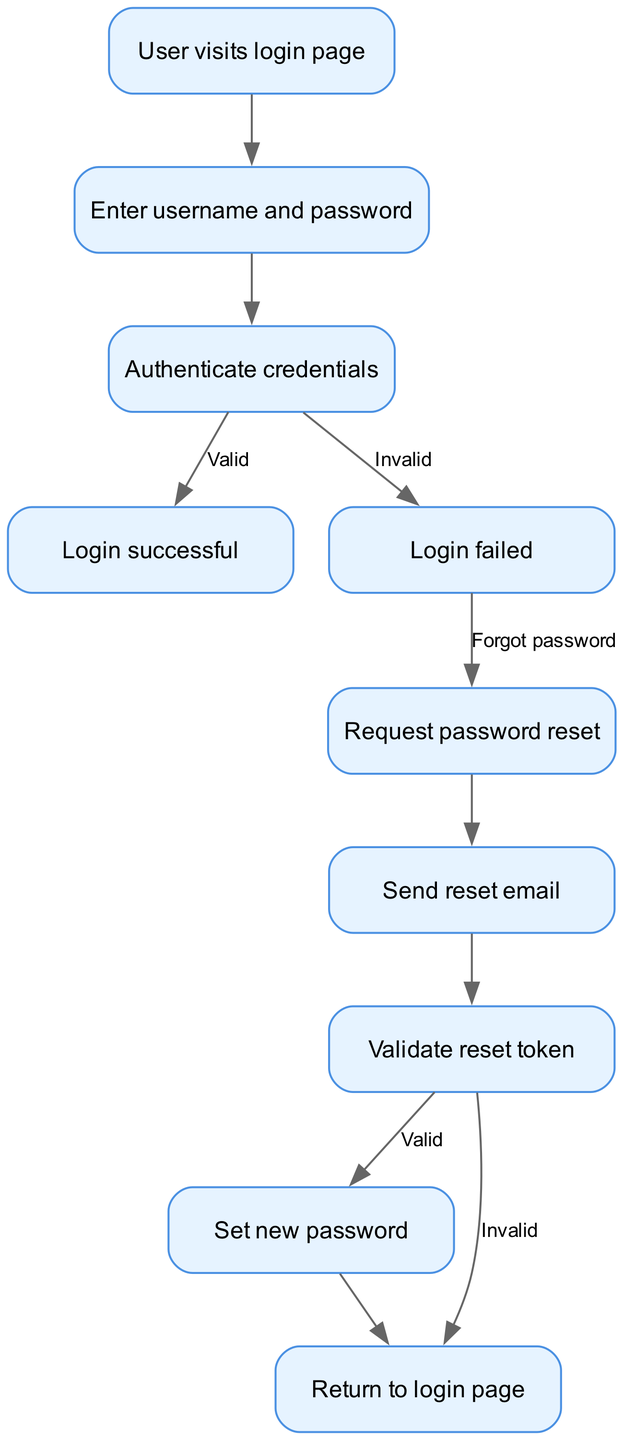What is the first action a user takes in the diagram? The diagram starts with the node labeled "User visits login page," which is the first action depicted in the flowchart.
Answer: User visits login page How many nodes are present in the diagram? By counting the distinct nodes listed in the data, there are a total of ten nodes present in the diagram.
Answer: 10 What happens if the user enters invalid credentials? The diagram shows that if the credentials are invalid, the flow leads to the "Login failed" node, indicating that the login attempt was unsuccessful.
Answer: Login failed What is the node that indicates a successful login? The node labeled "Login successful" signifies the point in the flow where the user has successfully authenticated their credentials.
Answer: Login successful What action is taken when the user requests a password reset? According to the diagram, when the user requests a password reset, the flow moves to the node labeled "Send reset email," indicating that an email will be sent for the password reset process.
Answer: Send reset email What is the final step in the flowchart? The final step in the flowchart is "Return to login page," which indicates the user will be redirected to the login interface after completing the process.
Answer: Return to login page If the reset token is invalid, what is the next step in the process? The flowchart shows that if the reset token is invalid, the flow leads directly to the "Return to login page" node, indicating the cancellation of the reset process.
Answer: Return to login page What action occurs after the password reset email is sent? After the reset email is sent, the next action in the flowchart is to "Validate reset token," which involves checking the token provided in the email.
Answer: Validate reset token What two outcomes can result from the authentication process? The authentication process can lead to either "Login successful" if credentials are valid or "Login failed" if credentials are invalid, resulting in two potential outcomes.
Answer: Login successful, Login failed 